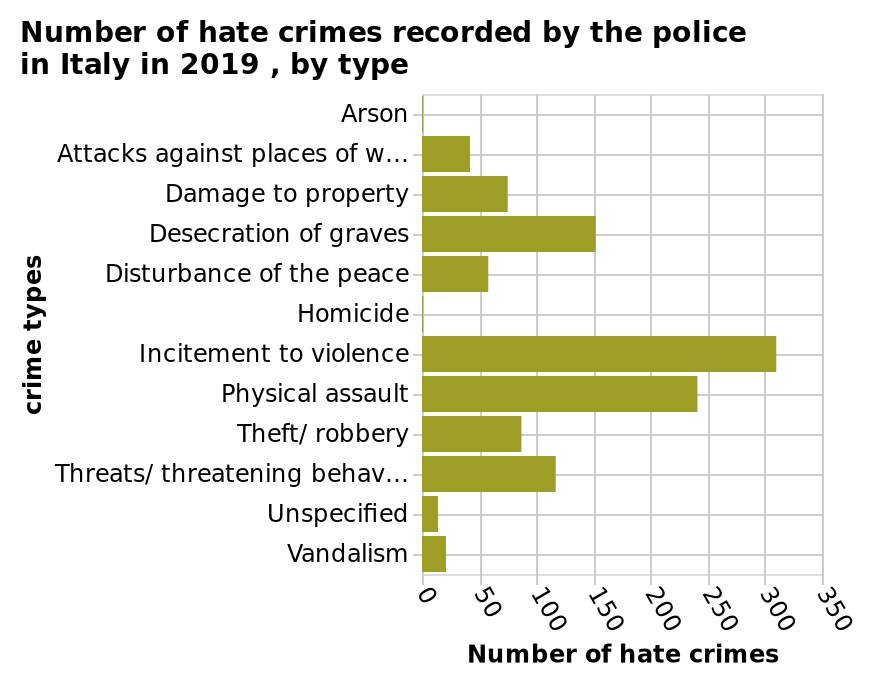<image>
please summary the statistics and relations of the chart Incitement to violence and physical threat are by far the most common forms of hate crime, followed by desecration of graves (at about half the rate of incitement to violence) and threat, theft and damage to property (about a third of incitement to violence). Homicide and arson are negligible. What is the second most common form of hate crime after incitement to violence?  Desecration of graves. What are the most common forms of hate crime?  Incitement to violence and physical threat. 